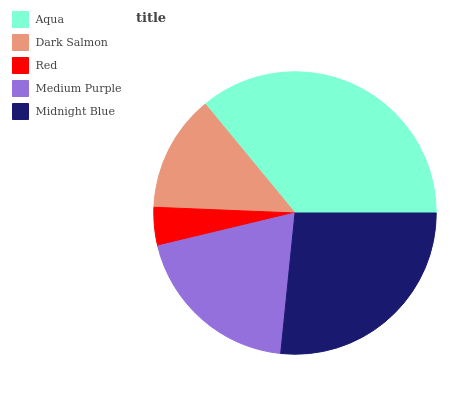Is Red the minimum?
Answer yes or no. Yes. Is Aqua the maximum?
Answer yes or no. Yes. Is Dark Salmon the minimum?
Answer yes or no. No. Is Dark Salmon the maximum?
Answer yes or no. No. Is Aqua greater than Dark Salmon?
Answer yes or no. Yes. Is Dark Salmon less than Aqua?
Answer yes or no. Yes. Is Dark Salmon greater than Aqua?
Answer yes or no. No. Is Aqua less than Dark Salmon?
Answer yes or no. No. Is Medium Purple the high median?
Answer yes or no. Yes. Is Medium Purple the low median?
Answer yes or no. Yes. Is Aqua the high median?
Answer yes or no. No. Is Aqua the low median?
Answer yes or no. No. 